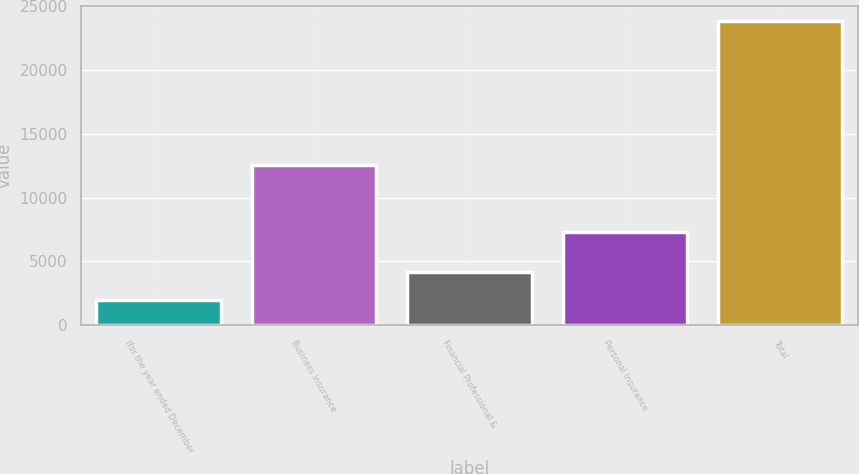<chart> <loc_0><loc_0><loc_500><loc_500><bar_chart><fcel>(for the year ended December<fcel>Business Insurance<fcel>Financial Professional &<fcel>Personal Insurance<fcel>Total<nl><fcel>2008<fcel>12580<fcel>4190.9<fcel>7291<fcel>23837<nl></chart> 